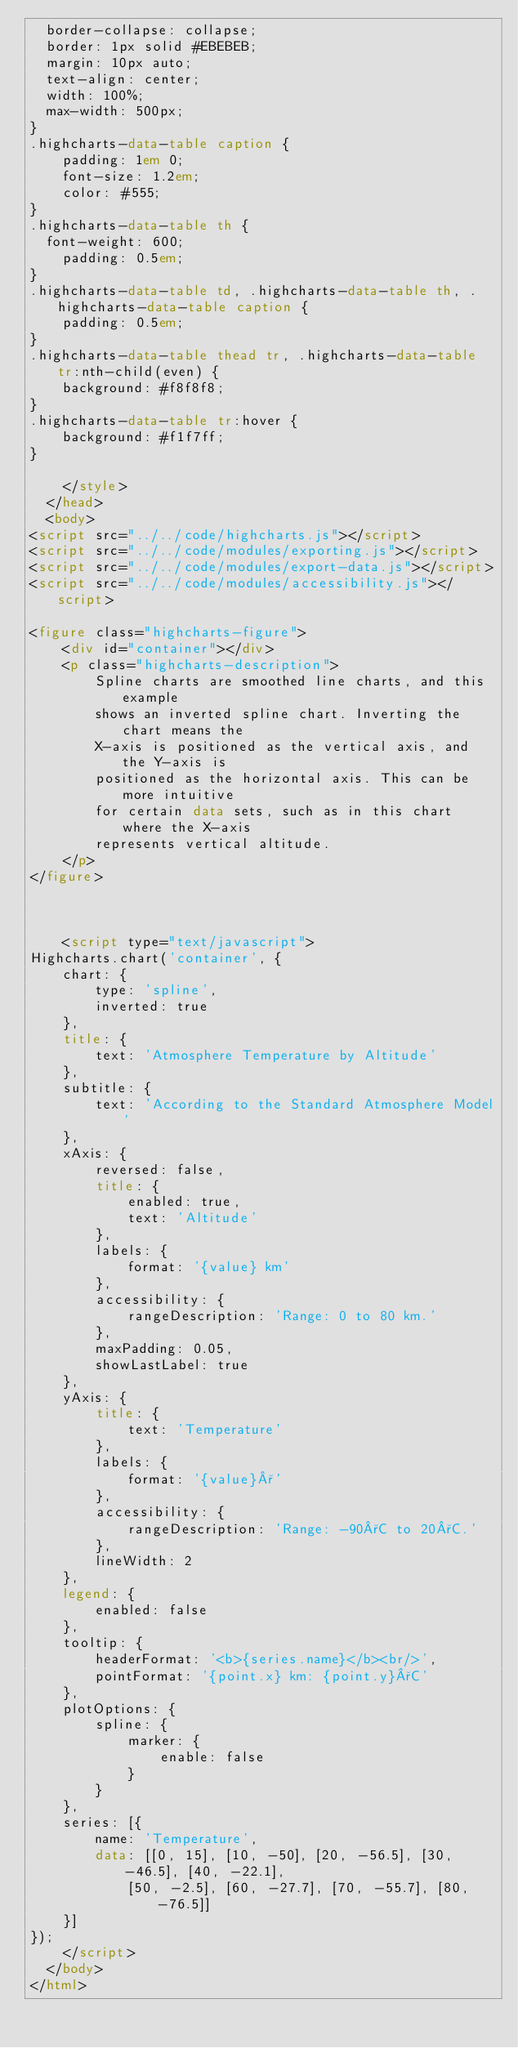Convert code to text. <code><loc_0><loc_0><loc_500><loc_500><_HTML_>	border-collapse: collapse;
	border: 1px solid #EBEBEB;
	margin: 10px auto;
	text-align: center;
	width: 100%;
	max-width: 500px;
}
.highcharts-data-table caption {
    padding: 1em 0;
    font-size: 1.2em;
    color: #555;
}
.highcharts-data-table th {
	font-weight: 600;
    padding: 0.5em;
}
.highcharts-data-table td, .highcharts-data-table th, .highcharts-data-table caption {
    padding: 0.5em;
}
.highcharts-data-table thead tr, .highcharts-data-table tr:nth-child(even) {
    background: #f8f8f8;
}
.highcharts-data-table tr:hover {
    background: #f1f7ff;
}

		</style>
	</head>
	<body>
<script src="../../code/highcharts.js"></script>
<script src="../../code/modules/exporting.js"></script>
<script src="../../code/modules/export-data.js"></script>
<script src="../../code/modules/accessibility.js"></script>

<figure class="highcharts-figure">
    <div id="container"></div>
    <p class="highcharts-description">
        Spline charts are smoothed line charts, and this example
        shows an inverted spline chart. Inverting the chart means the
        X-axis is positioned as the vertical axis, and the Y-axis is
        positioned as the horizontal axis. This can be more intuitive
        for certain data sets, such as in this chart where the X-axis
        represents vertical altitude.
    </p>
</figure>



		<script type="text/javascript">
Highcharts.chart('container', {
    chart: {
        type: 'spline',
        inverted: true
    },
    title: {
        text: 'Atmosphere Temperature by Altitude'
    },
    subtitle: {
        text: 'According to the Standard Atmosphere Model'
    },
    xAxis: {
        reversed: false,
        title: {
            enabled: true,
            text: 'Altitude'
        },
        labels: {
            format: '{value} km'
        },
        accessibility: {
            rangeDescription: 'Range: 0 to 80 km.'
        },
        maxPadding: 0.05,
        showLastLabel: true
    },
    yAxis: {
        title: {
            text: 'Temperature'
        },
        labels: {
            format: '{value}°'
        },
        accessibility: {
            rangeDescription: 'Range: -90°C to 20°C.'
        },
        lineWidth: 2
    },
    legend: {
        enabled: false
    },
    tooltip: {
        headerFormat: '<b>{series.name}</b><br/>',
        pointFormat: '{point.x} km: {point.y}°C'
    },
    plotOptions: {
        spline: {
            marker: {
                enable: false
            }
        }
    },
    series: [{
        name: 'Temperature',
        data: [[0, 15], [10, -50], [20, -56.5], [30, -46.5], [40, -22.1],
            [50, -2.5], [60, -27.7], [70, -55.7], [80, -76.5]]
    }]
});
		</script>
	</body>
</html>
</code> 